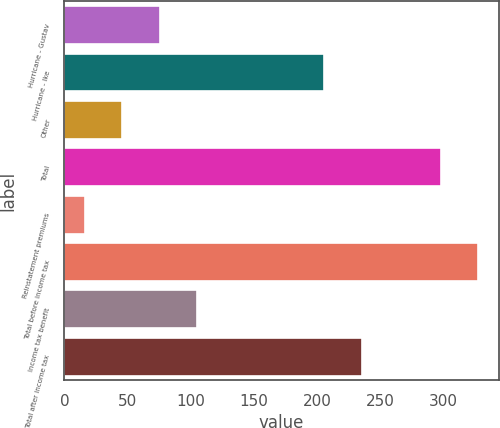<chart> <loc_0><loc_0><loc_500><loc_500><bar_chart><fcel>Hurricane - Gustav<fcel>Hurricane - Ike<fcel>Other<fcel>Total<fcel>Reinstatement premiums<fcel>Total before income tax<fcel>Income tax benefit<fcel>Total after income tax<nl><fcel>75.6<fcel>206<fcel>45.8<fcel>298<fcel>16<fcel>327.8<fcel>105.4<fcel>235.8<nl></chart> 